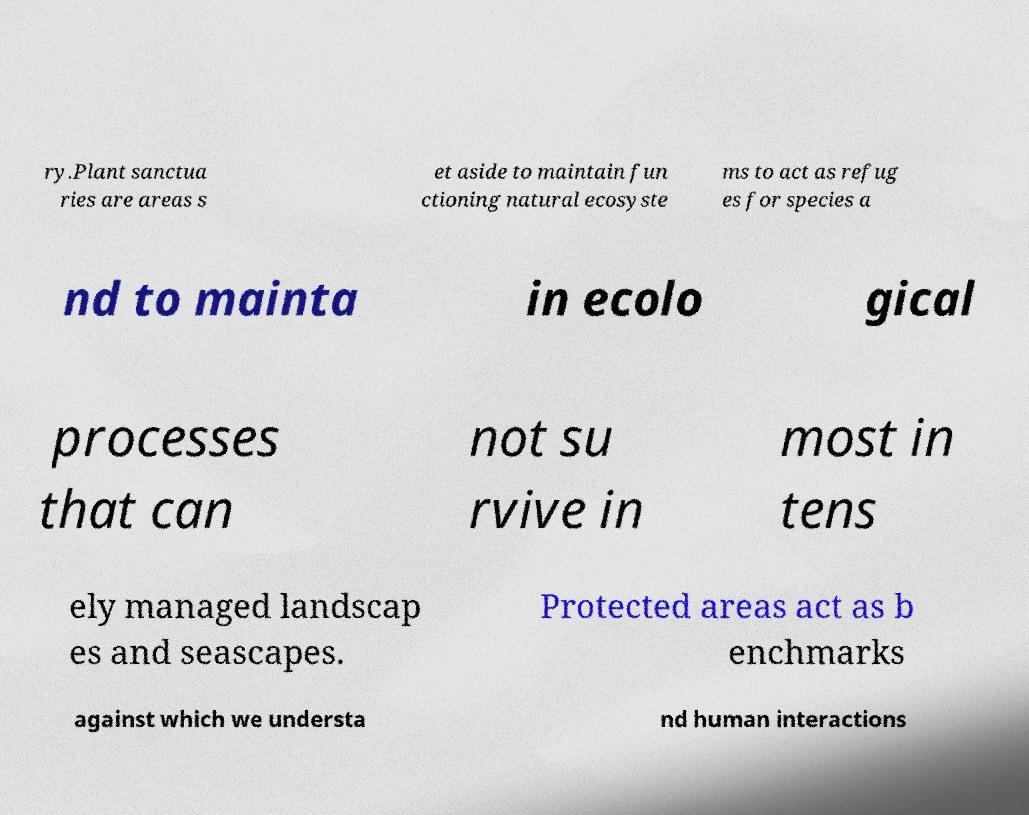Please read and relay the text visible in this image. What does it say? ry.Plant sanctua ries are areas s et aside to maintain fun ctioning natural ecosyste ms to act as refug es for species a nd to mainta in ecolo gical processes that can not su rvive in most in tens ely managed landscap es and seascapes. Protected areas act as b enchmarks against which we understa nd human interactions 